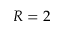Convert formula to latex. <formula><loc_0><loc_0><loc_500><loc_500>R = 2</formula> 